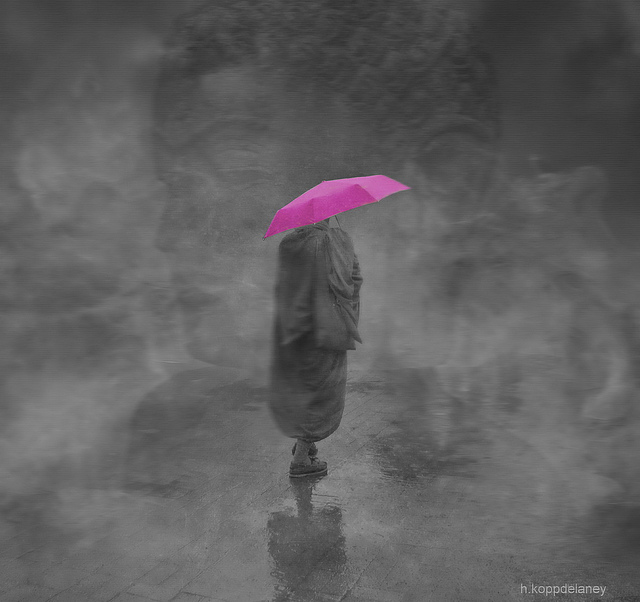How many images are superimposed in the picture? Based on the artistic blending techniques used, it seems that there is only one creatively edited image. The superimposition effect is achieved through the use of opacity and brush strokes that create a single cohesive image with a dreamlike quality. 